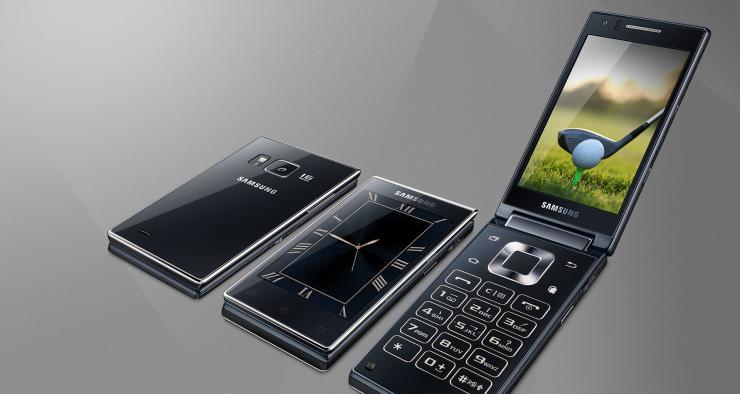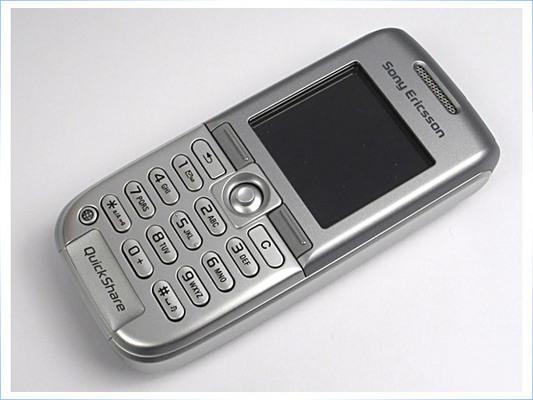The first image is the image on the left, the second image is the image on the right. Evaluate the accuracy of this statement regarding the images: "Three phones are laid out neatly side by side in one of the pictures.". Is it true? Answer yes or no. Yes. The first image is the image on the left, the second image is the image on the right. For the images displayed, is the sentence "The image on the left shows an opened flip phone." factually correct? Answer yes or no. Yes. 